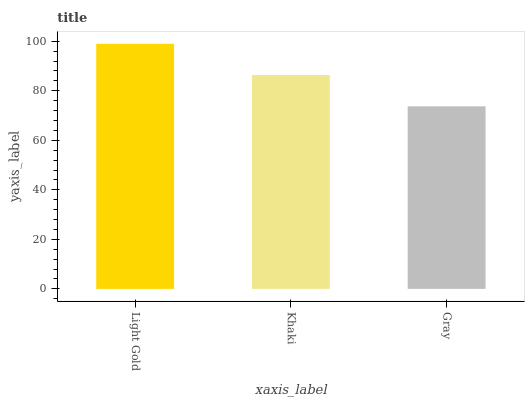Is Gray the minimum?
Answer yes or no. Yes. Is Light Gold the maximum?
Answer yes or no. Yes. Is Khaki the minimum?
Answer yes or no. No. Is Khaki the maximum?
Answer yes or no. No. Is Light Gold greater than Khaki?
Answer yes or no. Yes. Is Khaki less than Light Gold?
Answer yes or no. Yes. Is Khaki greater than Light Gold?
Answer yes or no. No. Is Light Gold less than Khaki?
Answer yes or no. No. Is Khaki the high median?
Answer yes or no. Yes. Is Khaki the low median?
Answer yes or no. Yes. Is Gray the high median?
Answer yes or no. No. Is Light Gold the low median?
Answer yes or no. No. 